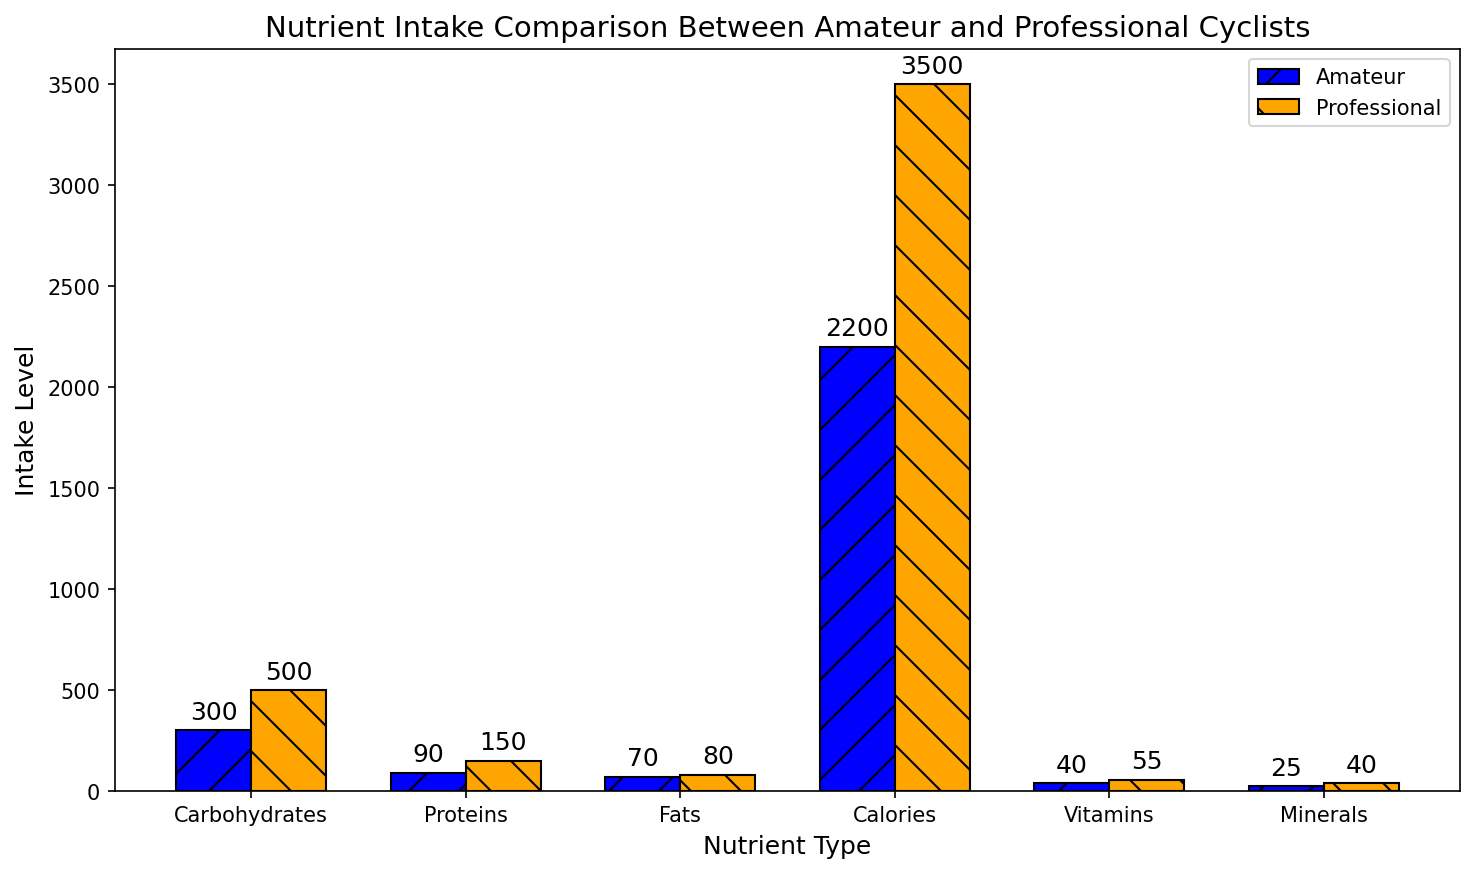Which nutrient has the highest intake level difference between Amateur and Professional cyclists? To find the nutrient with the highest intake level difference, calculate the difference for each nutrient by subtracting the Amateur intake level from the Professional intake level: Carbohydrates (500-300=200), Proteins (150-90=60), Fats (80-70=10), Calories (3500-2200=1300), Vitamins (55-40=15), Minerals (40-25=15). The nutrient with the greatest difference is Carbohydrates (200).
Answer: Carbohydrates Which nutrient has the smallest difference in intake levels between Amateur and Professional cyclists? Calculate the difference for each nutrient: Carbohydrates (200), Proteins (60), Fats (10), Calories (1300), Vitamins (15), Minerals (15). The smallest difference is seen with Fats (10).
Answer: Fats What is the total nutrient intake level for Professional cyclists? Sum the intake levels for all nutrients for Professional cyclists: Carbohydrates (500) + Proteins (150) + Fats (80) + Calories (3500) + Vitamins (55) + Minerals (40) = 4325.
Answer: 4325 Which nutrient type intake is higher for Amateur cyclists compared to Professional cyclists? Compare intake levels for each nutrient: Carbohydrates (300 vs 500), Proteins (90 vs 150), Fats (70 vs 80), Calories (2200 vs 3500), Vitamins (40 vs 55), and Minerals (25 vs 40). For all nutrients, Professional cyclists have higher intake levels.
Answer: None By how much do Professional cyclists exceed Amateur cyclists in their calorie intake? Subtract the calorie intake of Amateur cyclists from that of Professional cyclists: 3500 - 2200 = 1300.
Answer: 1300 For which nutrients do Professional cyclists have double or more than double the intake of Amateur cyclists? Compare each nutrient intake to see if the Professional cyclists' intake is at least double: Carbohydrates (500 vs 300, less than double), Proteins (150 vs 90, less), Fats (80 vs 70, less), Calories (3500 vs 2200, less than double), Vitamins (55 vs 40, less), Minerals (40 vs 25, less). None of the intakes meet the criteria.
Answer: None What is the average intake level of Vitamins and Minerals for Professional cyclists? Sum the intake levels of Vitamins (55) and Minerals (40) for Professional cyclists: 55 + 40 = 95. Divide by 2 to get the average: 95 / 2 = 47.5.
Answer: 47.5 